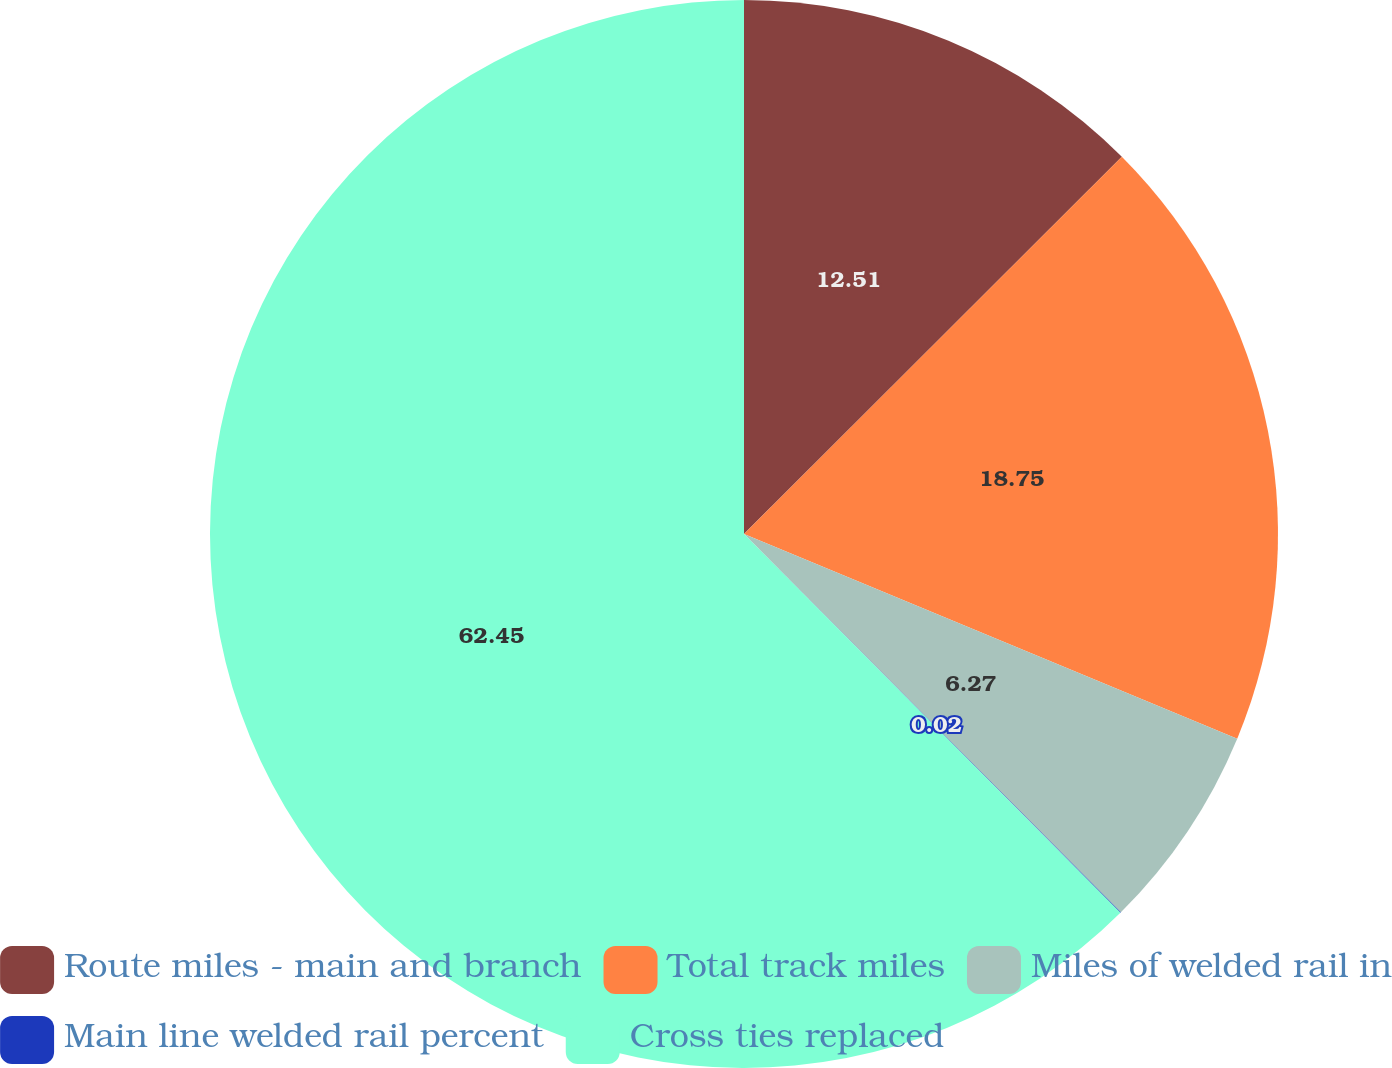Convert chart to OTSL. <chart><loc_0><loc_0><loc_500><loc_500><pie_chart><fcel>Route miles - main and branch<fcel>Total track miles<fcel>Miles of welded rail in<fcel>Main line welded rail percent<fcel>Cross ties replaced<nl><fcel>12.51%<fcel>18.75%<fcel>6.27%<fcel>0.02%<fcel>62.45%<nl></chart> 